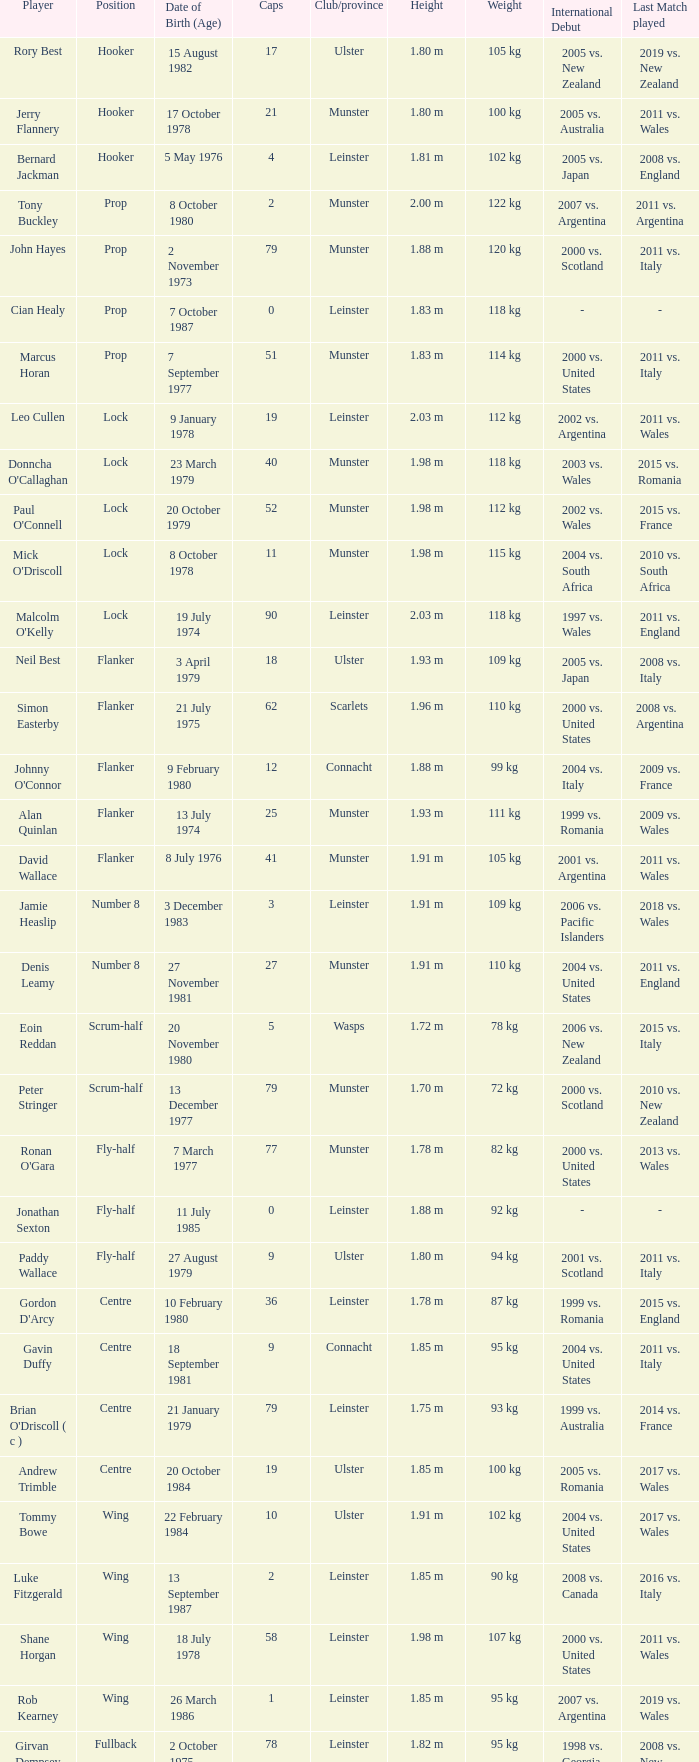How many Caps does the Club/province Munster, position of lock and Mick O'Driscoll have? 1.0. 